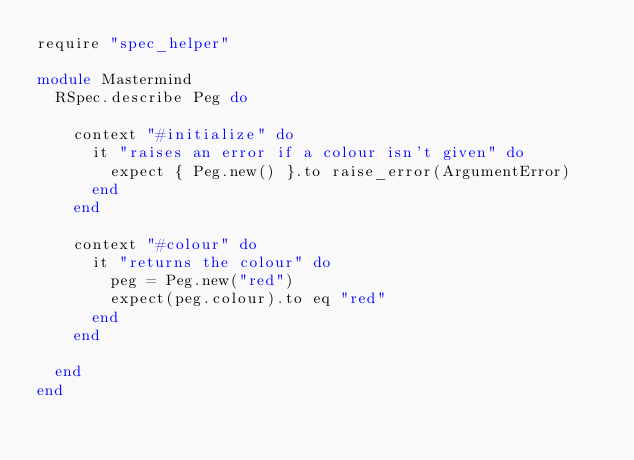Convert code to text. <code><loc_0><loc_0><loc_500><loc_500><_Ruby_>require "spec_helper"

module Mastermind
	RSpec.describe Peg do 
		
		context "#initialize" do 
			it "raises an error if a colour isn't given" do
				expect { Peg.new() }.to raise_error(ArgumentError)
			end
		end

		context "#colour" do
			it "returns the colour" do
				peg = Peg.new("red")
				expect(peg.colour).to eq "red"
			end
		end

	end
end</code> 